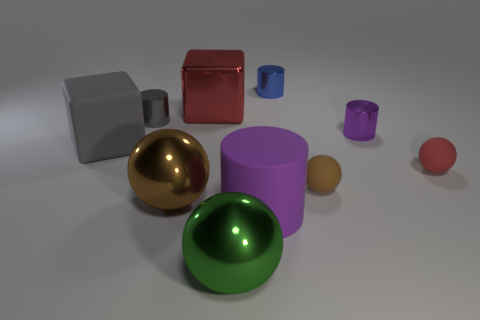What is the color of the rubber object in front of the large brown metal sphere?
Provide a succinct answer. Purple. Does the shiny ball in front of the brown metal sphere have the same size as the brown matte thing?
Offer a very short reply. No. There is a green thing that is the same shape as the tiny brown thing; what size is it?
Offer a very short reply. Large. Are there any other things that are the same size as the brown matte sphere?
Keep it short and to the point. Yes. Do the red matte thing and the tiny gray metallic object have the same shape?
Provide a short and direct response. No. Are there fewer green balls behind the green sphere than tiny gray things that are behind the gray rubber block?
Your answer should be compact. Yes. What number of shiny cylinders are on the right side of the red metallic block?
Keep it short and to the point. 2. There is a tiny metallic object that is on the left side of the blue cylinder; does it have the same shape as the large metallic thing behind the small purple cylinder?
Offer a very short reply. No. How many other objects are there of the same color as the large cylinder?
Your response must be concise. 1. There is a purple cylinder that is behind the tiny matte sphere to the right of the purple cylinder that is to the right of the small brown rubber sphere; what is it made of?
Give a very brief answer. Metal. 